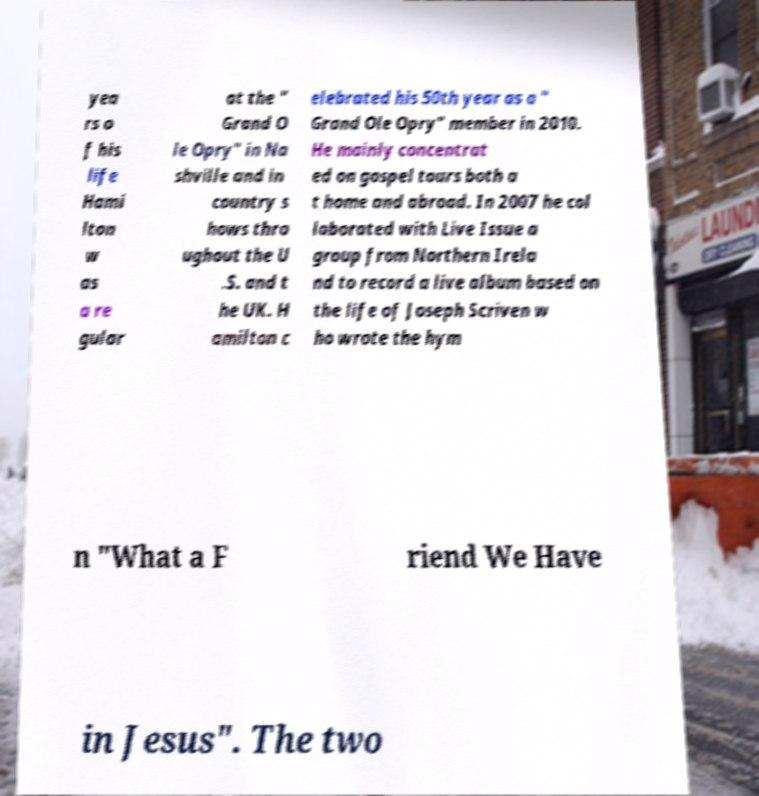Could you assist in decoding the text presented in this image and type it out clearly? yea rs o f his life Hami lton w as a re gular at the " Grand O le Opry" in Na shville and in country s hows thro ughout the U .S. and t he UK. H amilton c elebrated his 50th year as a " Grand Ole Opry" member in 2010. He mainly concentrat ed on gospel tours both a t home and abroad. In 2007 he col laborated with Live Issue a group from Northern Irela nd to record a live album based on the life of Joseph Scriven w ho wrote the hym n "What a F riend We Have in Jesus". The two 